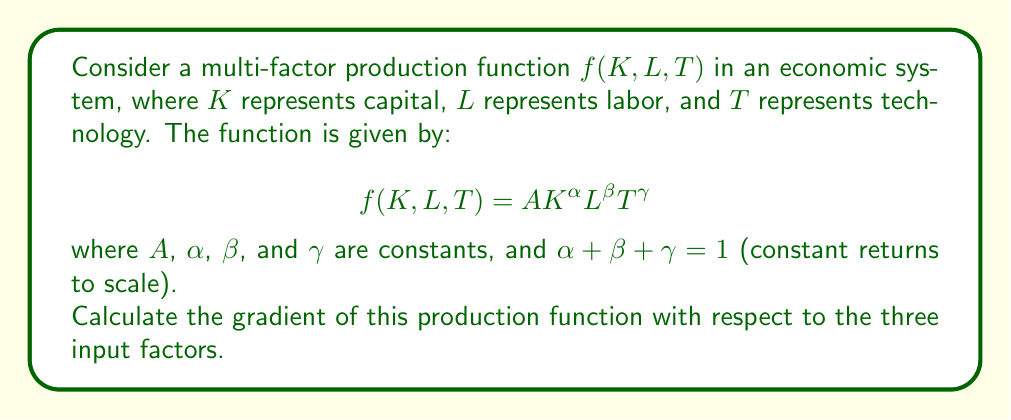Help me with this question. To find the gradient of the production function, we need to calculate the partial derivatives with respect to each input factor:

1. Partial derivative with respect to K:
   $$\frac{\partial f}{\partial K} = A\alpha K^{\alpha-1}L^{\beta}T^{\gamma}$$

2. Partial derivative with respect to L:
   $$\frac{\partial f}{\partial L} = A\beta K^{\alpha}L^{\beta-1}T^{\gamma}$$

3. Partial derivative with respect to T:
   $$\frac{\partial f}{\partial T} = A\gamma K^{\alpha}L^{\beta}T^{\gamma-1}$$

The gradient is a vector of these partial derivatives:

$$\nabla f(K, L, T) = \left(\frac{\partial f}{\partial K}, \frac{\partial f}{\partial L}, \frac{\partial f}{\partial T}\right)$$

Substituting the partial derivatives:

$$\nabla f(K, L, T) = \left(A\alpha K^{\alpha-1}L^{\beta}T^{\gamma}, A\beta K^{\alpha}L^{\beta-1}T^{\gamma}, A\gamma K^{\alpha}L^{\beta}T^{\gamma-1}\right)$$

This gradient represents the marginal products of each factor input, showing how output changes with respect to small changes in each input, holding the others constant. For a macroeconomist emphasizing structural factors, this gradient provides insights into the relative importance of capital, labor, and technology in driving economic growth and productivity.
Answer: $$\nabla f(K, L, T) = \left(A\alpha K^{\alpha-1}L^{\beta}T^{\gamma}, A\beta K^{\alpha}L^{\beta-1}T^{\gamma}, A\gamma K^{\alpha}L^{\beta}T^{\gamma-1}\right)$$ 